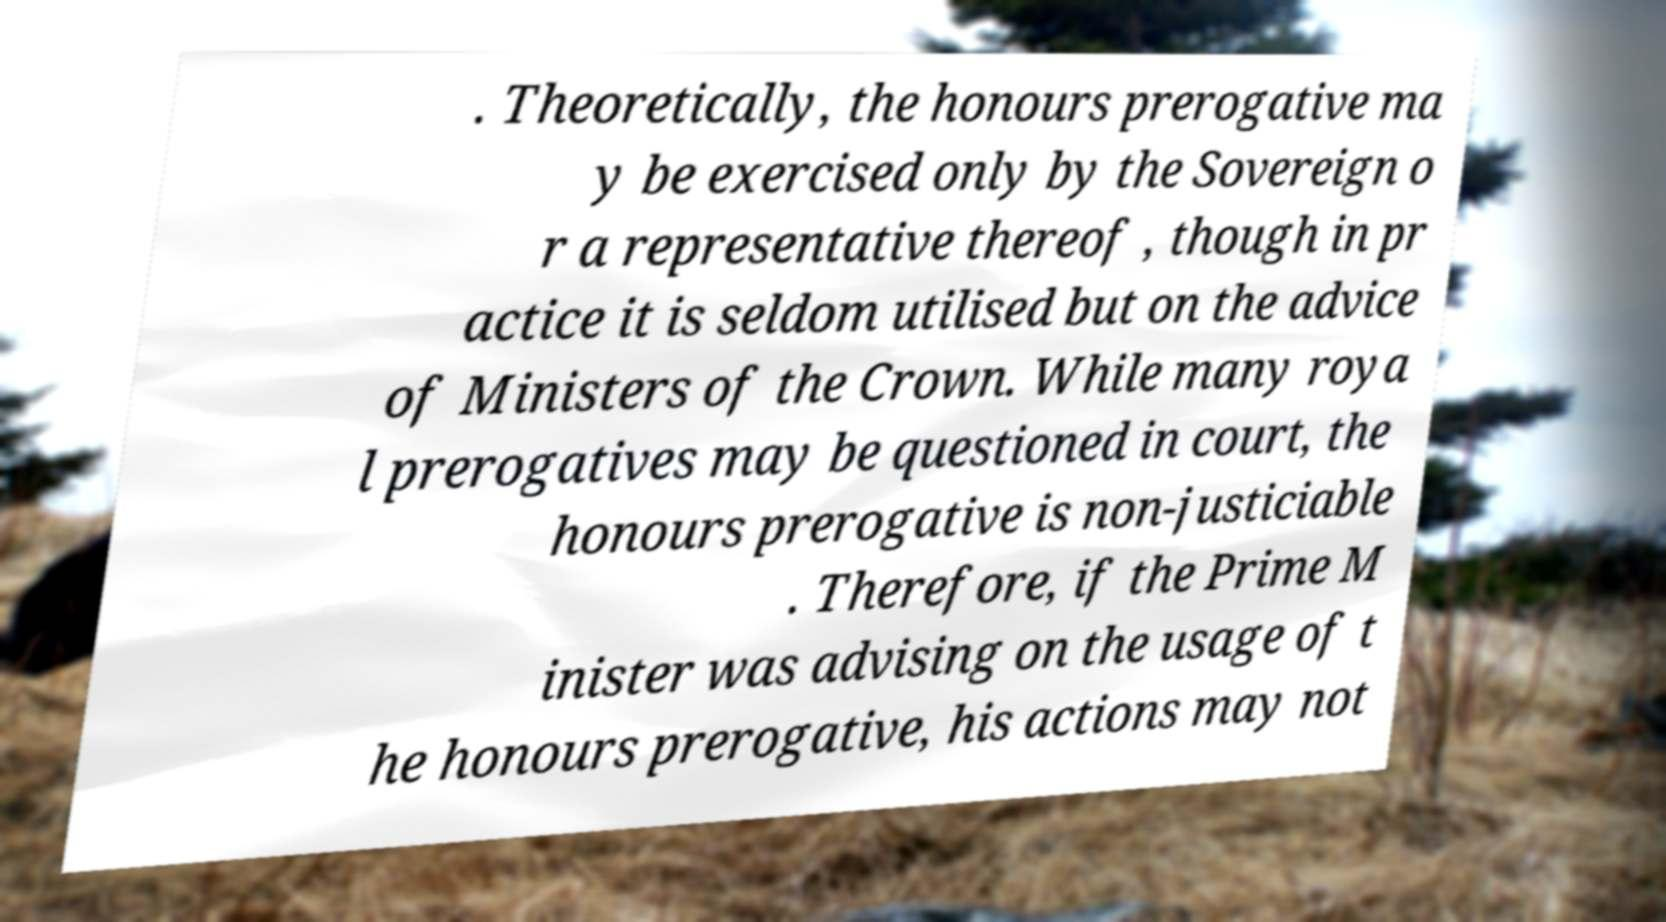I need the written content from this picture converted into text. Can you do that? . Theoretically, the honours prerogative ma y be exercised only by the Sovereign o r a representative thereof , though in pr actice it is seldom utilised but on the advice of Ministers of the Crown. While many roya l prerogatives may be questioned in court, the honours prerogative is non-justiciable . Therefore, if the Prime M inister was advising on the usage of t he honours prerogative, his actions may not 